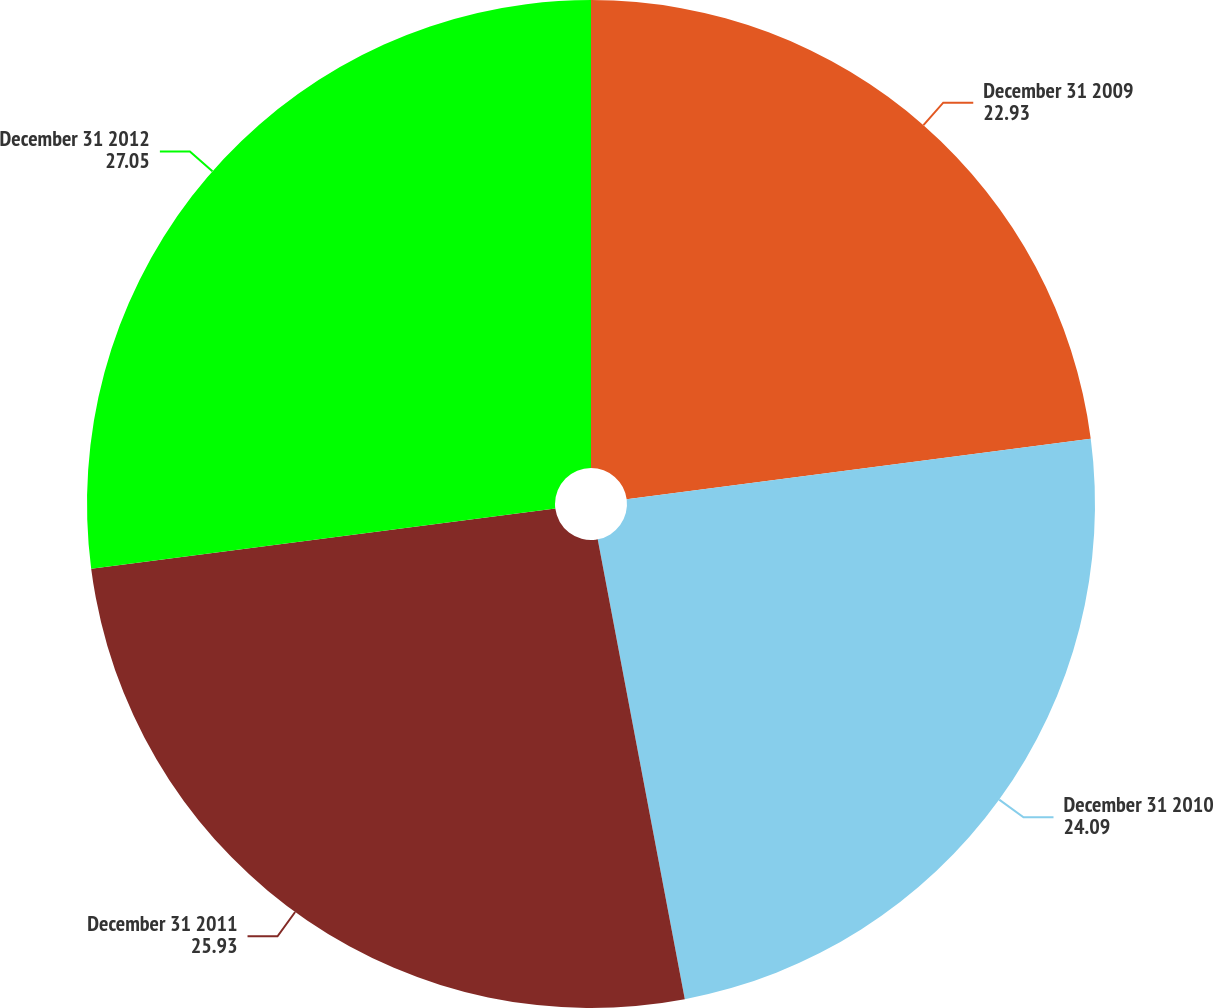Convert chart to OTSL. <chart><loc_0><loc_0><loc_500><loc_500><pie_chart><fcel>December 31 2009<fcel>December 31 2010<fcel>December 31 2011<fcel>December 31 2012<nl><fcel>22.93%<fcel>24.09%<fcel>25.93%<fcel>27.05%<nl></chart> 